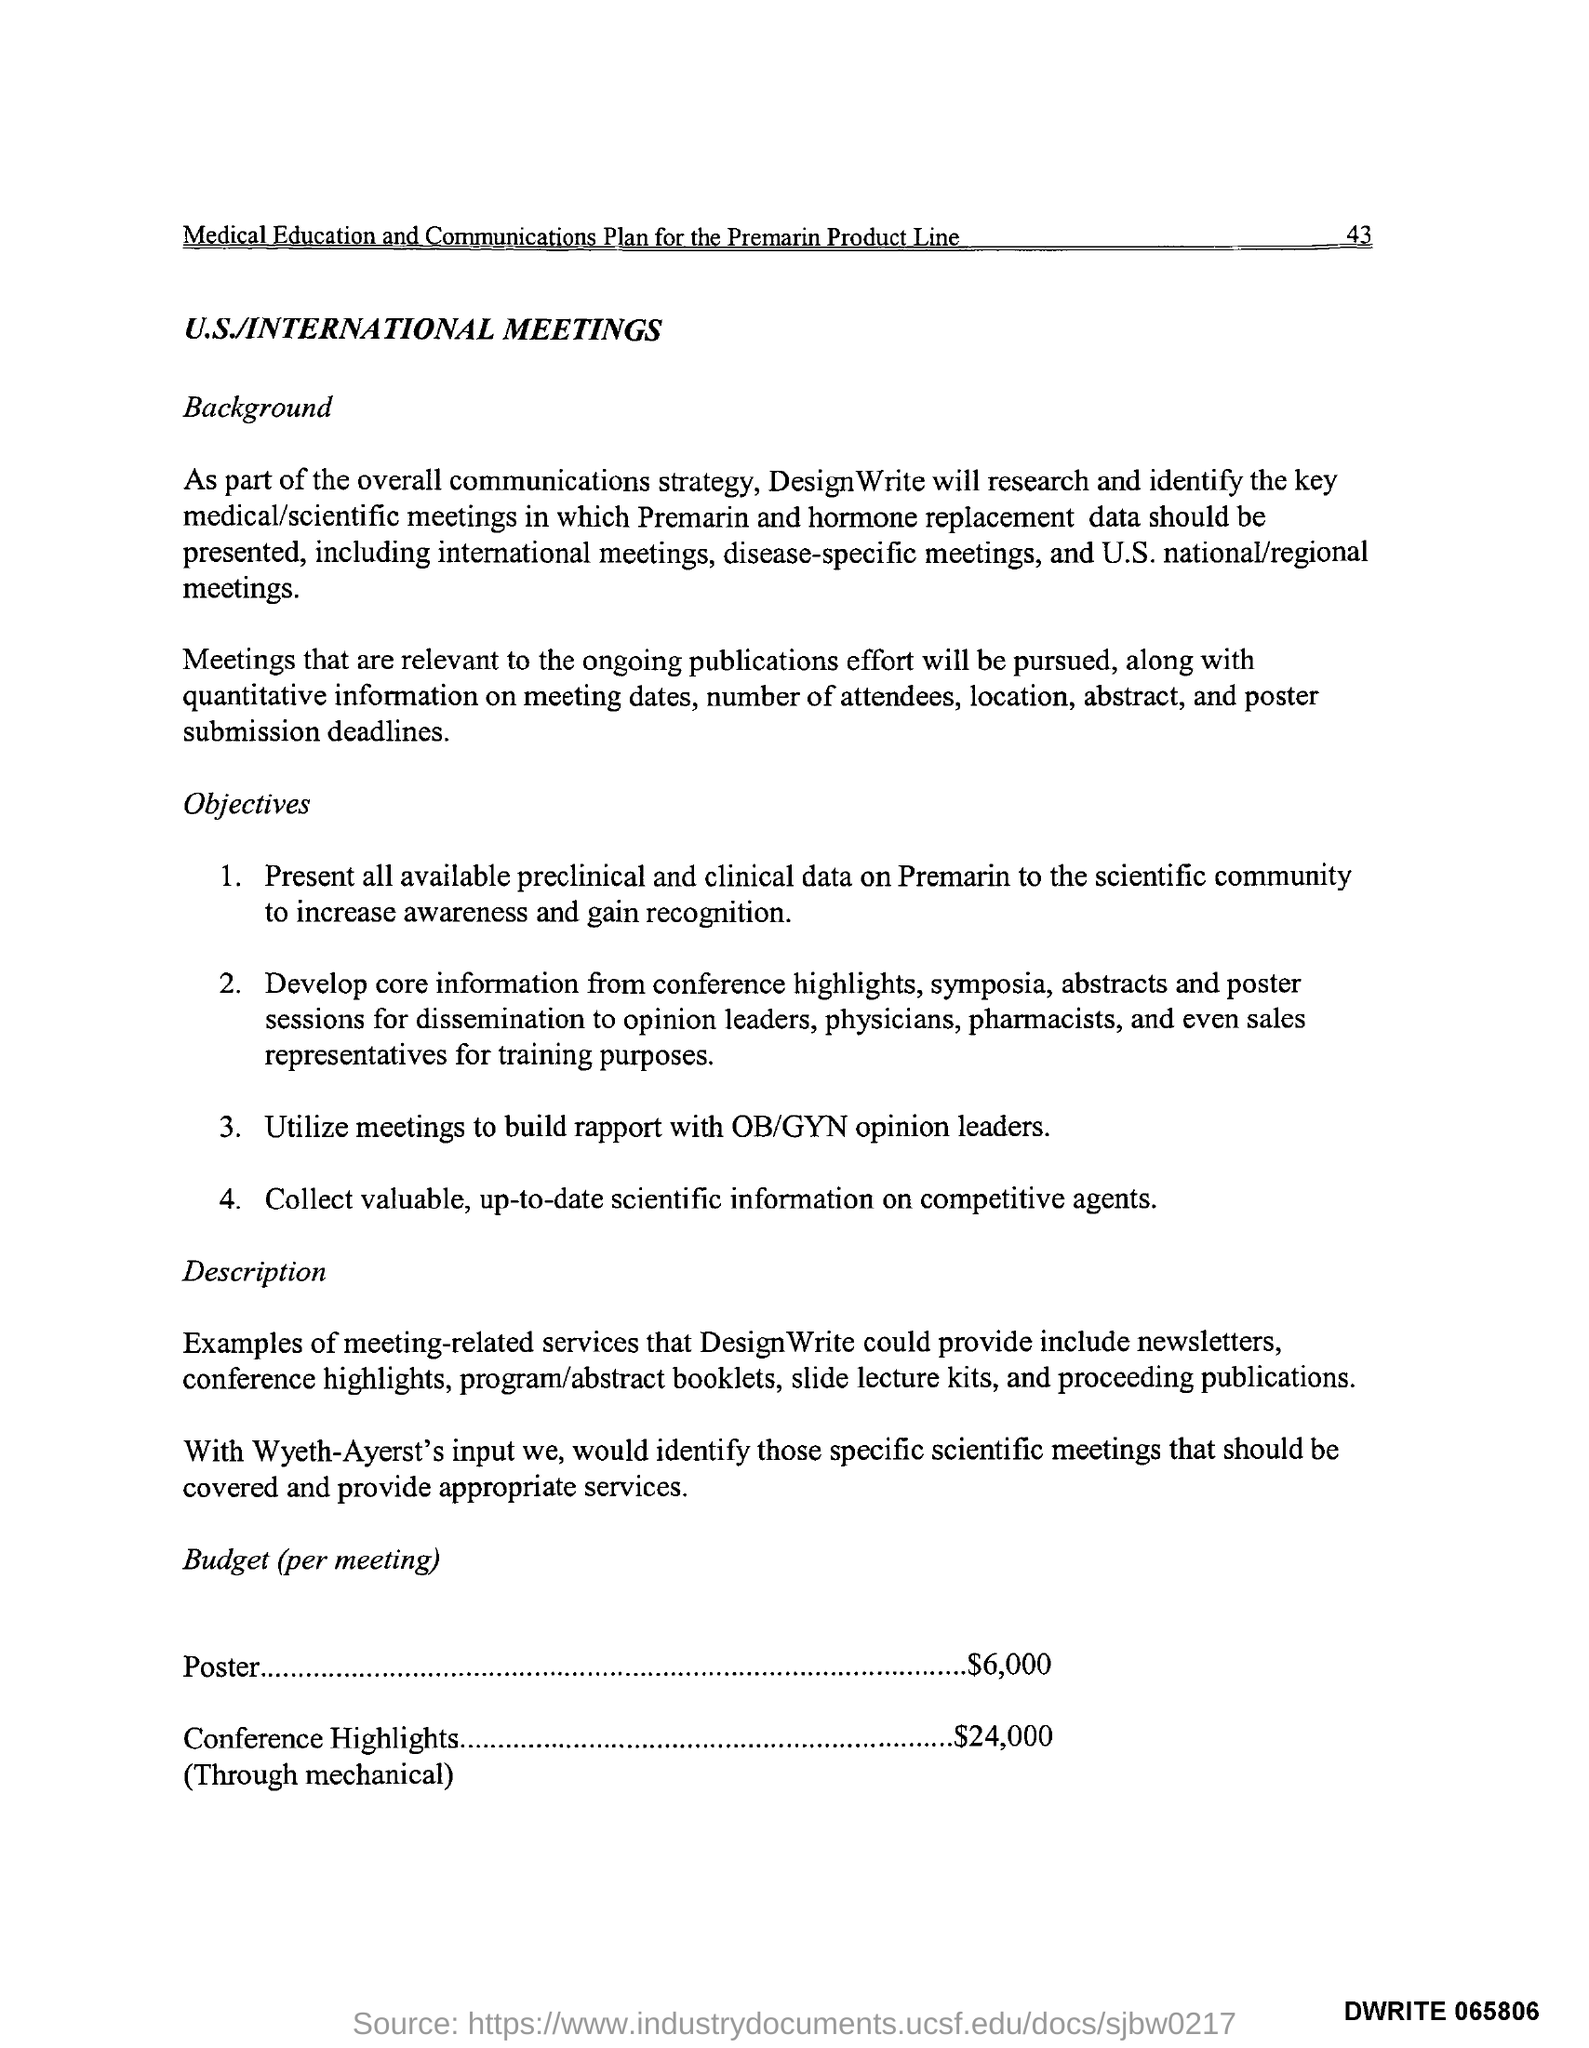Give some essential details in this illustration. The fourth objective of the meeting is to collect valuable and up-to-date scientific information on competitive agents. The expenditure on posters was $6,000. 